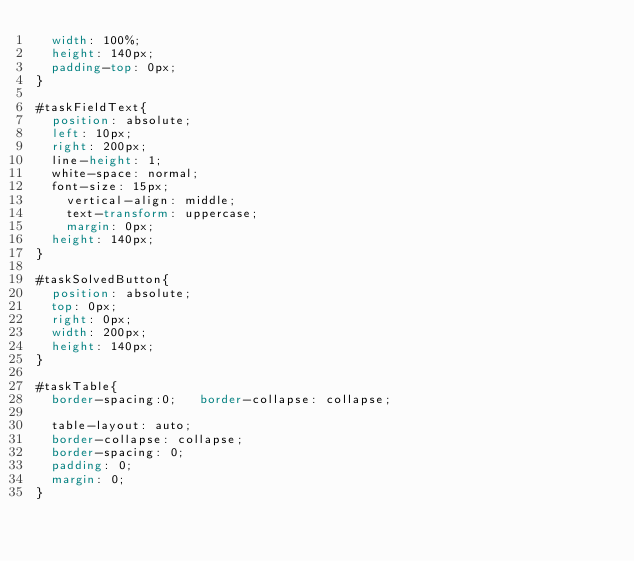<code> <loc_0><loc_0><loc_500><loc_500><_CSS_>	width: 100%;
	height: 140px;
	padding-top: 0px;	
}

#taskFieldText{	
	position: absolute;
	left: 10px;
	right: 200px;
	line-height: 1;
	white-space: normal;	
	font-size: 15px;
    vertical-align: middle;
    text-transform: uppercase;
    margin: 0px;
	height: 140px;	
}

#taskSolvedButton{	
	position: absolute;
	top: 0px;
	right: 0px;
	width: 200px;
	height: 140px;	
}

#taskTable{
	border-spacing:0; 	border-collapse: collapse; 

	table-layout: auto; 
	border-collapse: collapse; 
	border-spacing: 0;
	padding: 0;
	margin: 0;
}</code> 